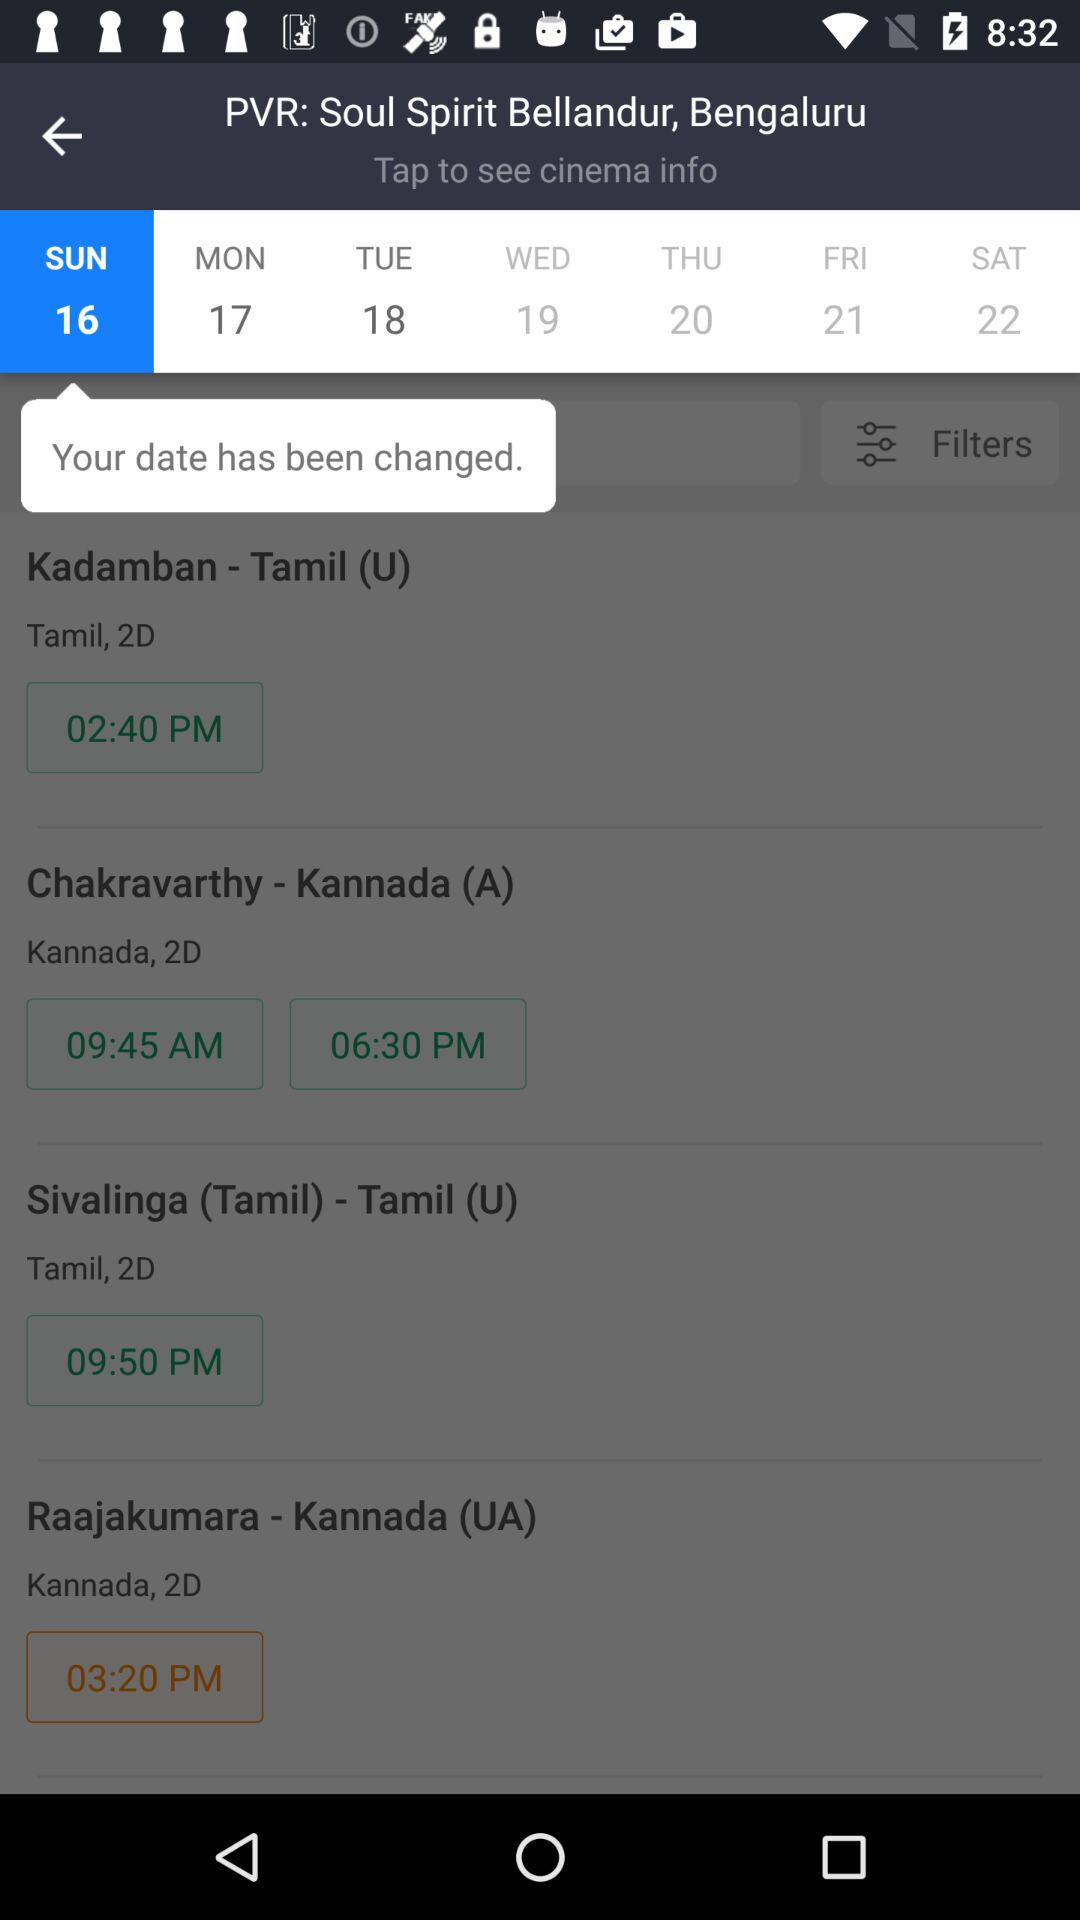What is the selected date? The selected date is Sunday, the 16th. 